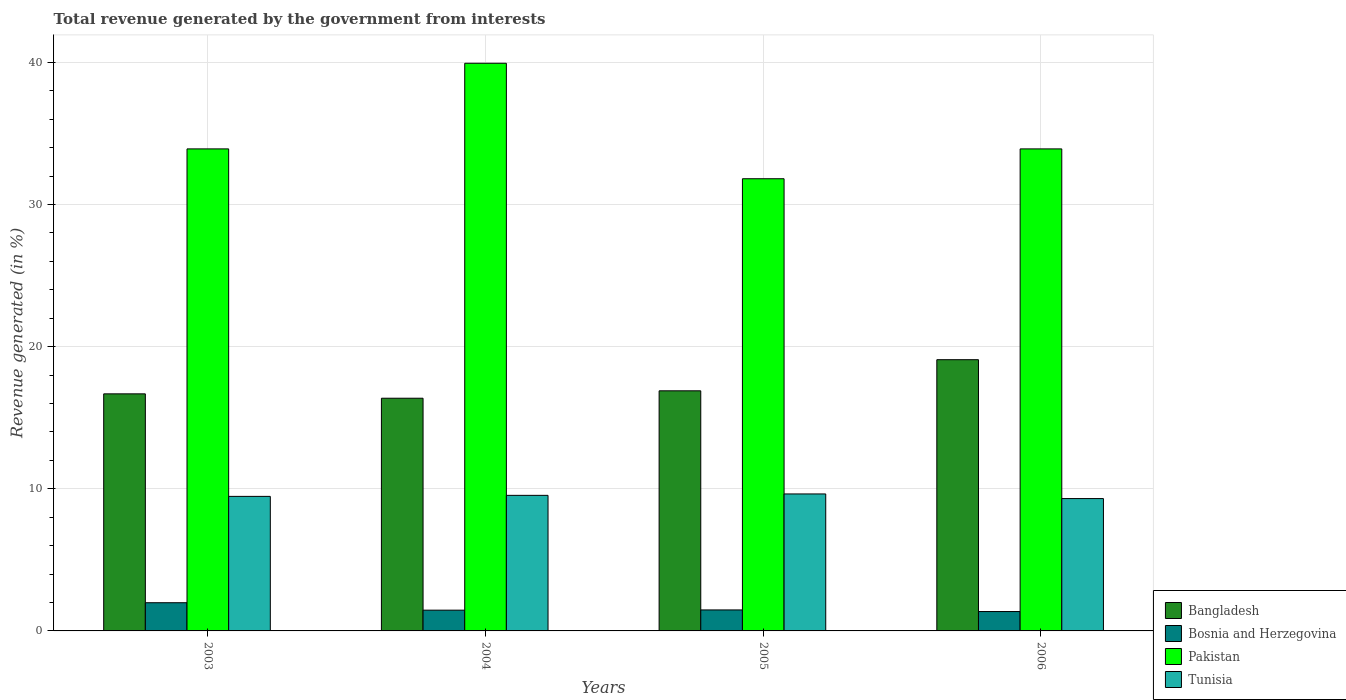How many groups of bars are there?
Keep it short and to the point. 4. Are the number of bars per tick equal to the number of legend labels?
Your response must be concise. Yes. Are the number of bars on each tick of the X-axis equal?
Your answer should be compact. Yes. How many bars are there on the 4th tick from the left?
Provide a succinct answer. 4. How many bars are there on the 1st tick from the right?
Provide a short and direct response. 4. What is the label of the 1st group of bars from the left?
Your response must be concise. 2003. In how many cases, is the number of bars for a given year not equal to the number of legend labels?
Provide a succinct answer. 0. What is the total revenue generated in Bosnia and Herzegovina in 2004?
Ensure brevity in your answer.  1.46. Across all years, what is the maximum total revenue generated in Bangladesh?
Your answer should be very brief. 19.08. Across all years, what is the minimum total revenue generated in Pakistan?
Offer a very short reply. 31.82. In which year was the total revenue generated in Tunisia minimum?
Offer a terse response. 2006. What is the total total revenue generated in Tunisia in the graph?
Provide a short and direct response. 37.95. What is the difference between the total revenue generated in Bosnia and Herzegovina in 2004 and that in 2005?
Provide a short and direct response. -0.02. What is the difference between the total revenue generated in Tunisia in 2005 and the total revenue generated in Bosnia and Herzegovina in 2006?
Give a very brief answer. 8.27. What is the average total revenue generated in Bangladesh per year?
Your answer should be very brief. 17.26. In the year 2004, what is the difference between the total revenue generated in Bangladesh and total revenue generated in Pakistan?
Give a very brief answer. -23.57. In how many years, is the total revenue generated in Tunisia greater than 28 %?
Provide a succinct answer. 0. What is the ratio of the total revenue generated in Tunisia in 2004 to that in 2006?
Make the answer very short. 1.02. Is the total revenue generated in Bangladesh in 2005 less than that in 2006?
Offer a terse response. Yes. Is the difference between the total revenue generated in Bangladesh in 2004 and 2006 greater than the difference between the total revenue generated in Pakistan in 2004 and 2006?
Keep it short and to the point. No. What is the difference between the highest and the second highest total revenue generated in Pakistan?
Keep it short and to the point. 6.03. What is the difference between the highest and the lowest total revenue generated in Bosnia and Herzegovina?
Ensure brevity in your answer.  0.62. In how many years, is the total revenue generated in Bangladesh greater than the average total revenue generated in Bangladesh taken over all years?
Keep it short and to the point. 1. What does the 2nd bar from the left in 2005 represents?
Ensure brevity in your answer.  Bosnia and Herzegovina. What does the 2nd bar from the right in 2006 represents?
Ensure brevity in your answer.  Pakistan. Is it the case that in every year, the sum of the total revenue generated in Tunisia and total revenue generated in Bangladesh is greater than the total revenue generated in Bosnia and Herzegovina?
Give a very brief answer. Yes. How many bars are there?
Give a very brief answer. 16. How many years are there in the graph?
Give a very brief answer. 4. Does the graph contain any zero values?
Give a very brief answer. No. Where does the legend appear in the graph?
Your response must be concise. Bottom right. How are the legend labels stacked?
Your answer should be compact. Vertical. What is the title of the graph?
Offer a very short reply. Total revenue generated by the government from interests. What is the label or title of the X-axis?
Your answer should be compact. Years. What is the label or title of the Y-axis?
Keep it short and to the point. Revenue generated (in %). What is the Revenue generated (in %) of Bangladesh in 2003?
Provide a short and direct response. 16.68. What is the Revenue generated (in %) of Bosnia and Herzegovina in 2003?
Offer a terse response. 1.98. What is the Revenue generated (in %) of Pakistan in 2003?
Ensure brevity in your answer.  33.92. What is the Revenue generated (in %) in Tunisia in 2003?
Offer a terse response. 9.47. What is the Revenue generated (in %) of Bangladesh in 2004?
Your answer should be very brief. 16.37. What is the Revenue generated (in %) in Bosnia and Herzegovina in 2004?
Your answer should be very brief. 1.46. What is the Revenue generated (in %) in Pakistan in 2004?
Provide a short and direct response. 39.94. What is the Revenue generated (in %) of Tunisia in 2004?
Your response must be concise. 9.54. What is the Revenue generated (in %) in Bangladesh in 2005?
Your answer should be compact. 16.89. What is the Revenue generated (in %) in Bosnia and Herzegovina in 2005?
Your response must be concise. 1.48. What is the Revenue generated (in %) of Pakistan in 2005?
Your response must be concise. 31.82. What is the Revenue generated (in %) of Tunisia in 2005?
Provide a short and direct response. 9.64. What is the Revenue generated (in %) of Bangladesh in 2006?
Your answer should be compact. 19.08. What is the Revenue generated (in %) in Bosnia and Herzegovina in 2006?
Provide a succinct answer. 1.36. What is the Revenue generated (in %) of Pakistan in 2006?
Offer a very short reply. 33.92. What is the Revenue generated (in %) of Tunisia in 2006?
Make the answer very short. 9.31. Across all years, what is the maximum Revenue generated (in %) of Bangladesh?
Offer a terse response. 19.08. Across all years, what is the maximum Revenue generated (in %) of Bosnia and Herzegovina?
Your response must be concise. 1.98. Across all years, what is the maximum Revenue generated (in %) in Pakistan?
Give a very brief answer. 39.94. Across all years, what is the maximum Revenue generated (in %) in Tunisia?
Offer a terse response. 9.64. Across all years, what is the minimum Revenue generated (in %) of Bangladesh?
Your answer should be compact. 16.37. Across all years, what is the minimum Revenue generated (in %) of Bosnia and Herzegovina?
Offer a terse response. 1.36. Across all years, what is the minimum Revenue generated (in %) in Pakistan?
Make the answer very short. 31.82. Across all years, what is the minimum Revenue generated (in %) of Tunisia?
Provide a succinct answer. 9.31. What is the total Revenue generated (in %) of Bangladesh in the graph?
Make the answer very short. 69.03. What is the total Revenue generated (in %) in Bosnia and Herzegovina in the graph?
Offer a very short reply. 6.29. What is the total Revenue generated (in %) of Pakistan in the graph?
Offer a terse response. 139.59. What is the total Revenue generated (in %) in Tunisia in the graph?
Offer a very short reply. 37.95. What is the difference between the Revenue generated (in %) in Bangladesh in 2003 and that in 2004?
Provide a short and direct response. 0.31. What is the difference between the Revenue generated (in %) of Bosnia and Herzegovina in 2003 and that in 2004?
Your response must be concise. 0.52. What is the difference between the Revenue generated (in %) in Pakistan in 2003 and that in 2004?
Make the answer very short. -6.03. What is the difference between the Revenue generated (in %) in Tunisia in 2003 and that in 2004?
Your response must be concise. -0.07. What is the difference between the Revenue generated (in %) in Bangladesh in 2003 and that in 2005?
Offer a very short reply. -0.21. What is the difference between the Revenue generated (in %) of Bosnia and Herzegovina in 2003 and that in 2005?
Make the answer very short. 0.51. What is the difference between the Revenue generated (in %) in Pakistan in 2003 and that in 2005?
Give a very brief answer. 2.1. What is the difference between the Revenue generated (in %) of Tunisia in 2003 and that in 2005?
Provide a short and direct response. -0.17. What is the difference between the Revenue generated (in %) of Bangladesh in 2003 and that in 2006?
Provide a succinct answer. -2.4. What is the difference between the Revenue generated (in %) of Bosnia and Herzegovina in 2003 and that in 2006?
Your answer should be compact. 0.62. What is the difference between the Revenue generated (in %) in Pakistan in 2003 and that in 2006?
Ensure brevity in your answer.  0. What is the difference between the Revenue generated (in %) in Tunisia in 2003 and that in 2006?
Your answer should be very brief. 0.15. What is the difference between the Revenue generated (in %) in Bangladesh in 2004 and that in 2005?
Offer a very short reply. -0.52. What is the difference between the Revenue generated (in %) in Bosnia and Herzegovina in 2004 and that in 2005?
Ensure brevity in your answer.  -0.02. What is the difference between the Revenue generated (in %) of Pakistan in 2004 and that in 2005?
Ensure brevity in your answer.  8.13. What is the difference between the Revenue generated (in %) of Tunisia in 2004 and that in 2005?
Offer a very short reply. -0.1. What is the difference between the Revenue generated (in %) in Bangladesh in 2004 and that in 2006?
Your answer should be very brief. -2.71. What is the difference between the Revenue generated (in %) in Bosnia and Herzegovina in 2004 and that in 2006?
Your response must be concise. 0.1. What is the difference between the Revenue generated (in %) of Pakistan in 2004 and that in 2006?
Ensure brevity in your answer.  6.03. What is the difference between the Revenue generated (in %) in Tunisia in 2004 and that in 2006?
Your response must be concise. 0.23. What is the difference between the Revenue generated (in %) in Bangladesh in 2005 and that in 2006?
Your answer should be very brief. -2.19. What is the difference between the Revenue generated (in %) in Bosnia and Herzegovina in 2005 and that in 2006?
Offer a very short reply. 0.11. What is the difference between the Revenue generated (in %) in Pakistan in 2005 and that in 2006?
Ensure brevity in your answer.  -2.1. What is the difference between the Revenue generated (in %) of Tunisia in 2005 and that in 2006?
Provide a short and direct response. 0.33. What is the difference between the Revenue generated (in %) in Bangladesh in 2003 and the Revenue generated (in %) in Bosnia and Herzegovina in 2004?
Offer a very short reply. 15.22. What is the difference between the Revenue generated (in %) of Bangladesh in 2003 and the Revenue generated (in %) of Pakistan in 2004?
Keep it short and to the point. -23.26. What is the difference between the Revenue generated (in %) in Bangladesh in 2003 and the Revenue generated (in %) in Tunisia in 2004?
Ensure brevity in your answer.  7.14. What is the difference between the Revenue generated (in %) of Bosnia and Herzegovina in 2003 and the Revenue generated (in %) of Pakistan in 2004?
Offer a very short reply. -37.96. What is the difference between the Revenue generated (in %) in Bosnia and Herzegovina in 2003 and the Revenue generated (in %) in Tunisia in 2004?
Your answer should be compact. -7.55. What is the difference between the Revenue generated (in %) of Pakistan in 2003 and the Revenue generated (in %) of Tunisia in 2004?
Your answer should be very brief. 24.38. What is the difference between the Revenue generated (in %) in Bangladesh in 2003 and the Revenue generated (in %) in Bosnia and Herzegovina in 2005?
Provide a succinct answer. 15.2. What is the difference between the Revenue generated (in %) of Bangladesh in 2003 and the Revenue generated (in %) of Pakistan in 2005?
Provide a succinct answer. -15.14. What is the difference between the Revenue generated (in %) of Bangladesh in 2003 and the Revenue generated (in %) of Tunisia in 2005?
Keep it short and to the point. 7.04. What is the difference between the Revenue generated (in %) of Bosnia and Herzegovina in 2003 and the Revenue generated (in %) of Pakistan in 2005?
Provide a short and direct response. -29.83. What is the difference between the Revenue generated (in %) in Bosnia and Herzegovina in 2003 and the Revenue generated (in %) in Tunisia in 2005?
Provide a succinct answer. -7.65. What is the difference between the Revenue generated (in %) of Pakistan in 2003 and the Revenue generated (in %) of Tunisia in 2005?
Your answer should be compact. 24.28. What is the difference between the Revenue generated (in %) of Bangladesh in 2003 and the Revenue generated (in %) of Bosnia and Herzegovina in 2006?
Ensure brevity in your answer.  15.32. What is the difference between the Revenue generated (in %) of Bangladesh in 2003 and the Revenue generated (in %) of Pakistan in 2006?
Your answer should be very brief. -17.23. What is the difference between the Revenue generated (in %) in Bangladesh in 2003 and the Revenue generated (in %) in Tunisia in 2006?
Ensure brevity in your answer.  7.37. What is the difference between the Revenue generated (in %) in Bosnia and Herzegovina in 2003 and the Revenue generated (in %) in Pakistan in 2006?
Your response must be concise. -31.93. What is the difference between the Revenue generated (in %) of Bosnia and Herzegovina in 2003 and the Revenue generated (in %) of Tunisia in 2006?
Your response must be concise. -7.33. What is the difference between the Revenue generated (in %) of Pakistan in 2003 and the Revenue generated (in %) of Tunisia in 2006?
Your response must be concise. 24.6. What is the difference between the Revenue generated (in %) in Bangladesh in 2004 and the Revenue generated (in %) in Bosnia and Herzegovina in 2005?
Offer a very short reply. 14.9. What is the difference between the Revenue generated (in %) of Bangladesh in 2004 and the Revenue generated (in %) of Pakistan in 2005?
Your answer should be very brief. -15.44. What is the difference between the Revenue generated (in %) in Bangladesh in 2004 and the Revenue generated (in %) in Tunisia in 2005?
Provide a short and direct response. 6.74. What is the difference between the Revenue generated (in %) of Bosnia and Herzegovina in 2004 and the Revenue generated (in %) of Pakistan in 2005?
Keep it short and to the point. -30.36. What is the difference between the Revenue generated (in %) of Bosnia and Herzegovina in 2004 and the Revenue generated (in %) of Tunisia in 2005?
Your answer should be very brief. -8.18. What is the difference between the Revenue generated (in %) of Pakistan in 2004 and the Revenue generated (in %) of Tunisia in 2005?
Provide a succinct answer. 30.3. What is the difference between the Revenue generated (in %) in Bangladesh in 2004 and the Revenue generated (in %) in Bosnia and Herzegovina in 2006?
Provide a short and direct response. 15.01. What is the difference between the Revenue generated (in %) of Bangladesh in 2004 and the Revenue generated (in %) of Pakistan in 2006?
Your response must be concise. -17.54. What is the difference between the Revenue generated (in %) in Bangladesh in 2004 and the Revenue generated (in %) in Tunisia in 2006?
Your answer should be compact. 7.06. What is the difference between the Revenue generated (in %) of Bosnia and Herzegovina in 2004 and the Revenue generated (in %) of Pakistan in 2006?
Make the answer very short. -32.46. What is the difference between the Revenue generated (in %) of Bosnia and Herzegovina in 2004 and the Revenue generated (in %) of Tunisia in 2006?
Give a very brief answer. -7.85. What is the difference between the Revenue generated (in %) of Pakistan in 2004 and the Revenue generated (in %) of Tunisia in 2006?
Give a very brief answer. 30.63. What is the difference between the Revenue generated (in %) in Bangladesh in 2005 and the Revenue generated (in %) in Bosnia and Herzegovina in 2006?
Make the answer very short. 15.53. What is the difference between the Revenue generated (in %) of Bangladesh in 2005 and the Revenue generated (in %) of Pakistan in 2006?
Give a very brief answer. -17.02. What is the difference between the Revenue generated (in %) of Bangladesh in 2005 and the Revenue generated (in %) of Tunisia in 2006?
Provide a short and direct response. 7.58. What is the difference between the Revenue generated (in %) of Bosnia and Herzegovina in 2005 and the Revenue generated (in %) of Pakistan in 2006?
Offer a very short reply. -32.44. What is the difference between the Revenue generated (in %) of Bosnia and Herzegovina in 2005 and the Revenue generated (in %) of Tunisia in 2006?
Provide a short and direct response. -7.83. What is the difference between the Revenue generated (in %) of Pakistan in 2005 and the Revenue generated (in %) of Tunisia in 2006?
Offer a very short reply. 22.5. What is the average Revenue generated (in %) in Bangladesh per year?
Ensure brevity in your answer.  17.26. What is the average Revenue generated (in %) of Bosnia and Herzegovina per year?
Your answer should be very brief. 1.57. What is the average Revenue generated (in %) in Pakistan per year?
Keep it short and to the point. 34.9. What is the average Revenue generated (in %) of Tunisia per year?
Make the answer very short. 9.49. In the year 2003, what is the difference between the Revenue generated (in %) of Bangladesh and Revenue generated (in %) of Bosnia and Herzegovina?
Your response must be concise. 14.7. In the year 2003, what is the difference between the Revenue generated (in %) of Bangladesh and Revenue generated (in %) of Pakistan?
Give a very brief answer. -17.24. In the year 2003, what is the difference between the Revenue generated (in %) in Bangladesh and Revenue generated (in %) in Tunisia?
Provide a short and direct response. 7.21. In the year 2003, what is the difference between the Revenue generated (in %) in Bosnia and Herzegovina and Revenue generated (in %) in Pakistan?
Provide a succinct answer. -31.93. In the year 2003, what is the difference between the Revenue generated (in %) in Bosnia and Herzegovina and Revenue generated (in %) in Tunisia?
Provide a short and direct response. -7.48. In the year 2003, what is the difference between the Revenue generated (in %) in Pakistan and Revenue generated (in %) in Tunisia?
Ensure brevity in your answer.  24.45. In the year 2004, what is the difference between the Revenue generated (in %) in Bangladesh and Revenue generated (in %) in Bosnia and Herzegovina?
Your answer should be compact. 14.91. In the year 2004, what is the difference between the Revenue generated (in %) in Bangladesh and Revenue generated (in %) in Pakistan?
Make the answer very short. -23.57. In the year 2004, what is the difference between the Revenue generated (in %) of Bangladesh and Revenue generated (in %) of Tunisia?
Provide a short and direct response. 6.83. In the year 2004, what is the difference between the Revenue generated (in %) of Bosnia and Herzegovina and Revenue generated (in %) of Pakistan?
Ensure brevity in your answer.  -38.48. In the year 2004, what is the difference between the Revenue generated (in %) of Bosnia and Herzegovina and Revenue generated (in %) of Tunisia?
Give a very brief answer. -8.08. In the year 2004, what is the difference between the Revenue generated (in %) in Pakistan and Revenue generated (in %) in Tunisia?
Your answer should be compact. 30.4. In the year 2005, what is the difference between the Revenue generated (in %) in Bangladesh and Revenue generated (in %) in Bosnia and Herzegovina?
Offer a terse response. 15.42. In the year 2005, what is the difference between the Revenue generated (in %) in Bangladesh and Revenue generated (in %) in Pakistan?
Provide a short and direct response. -14.92. In the year 2005, what is the difference between the Revenue generated (in %) in Bangladesh and Revenue generated (in %) in Tunisia?
Make the answer very short. 7.26. In the year 2005, what is the difference between the Revenue generated (in %) of Bosnia and Herzegovina and Revenue generated (in %) of Pakistan?
Provide a succinct answer. -30.34. In the year 2005, what is the difference between the Revenue generated (in %) of Bosnia and Herzegovina and Revenue generated (in %) of Tunisia?
Provide a short and direct response. -8.16. In the year 2005, what is the difference between the Revenue generated (in %) in Pakistan and Revenue generated (in %) in Tunisia?
Your answer should be compact. 22.18. In the year 2006, what is the difference between the Revenue generated (in %) of Bangladesh and Revenue generated (in %) of Bosnia and Herzegovina?
Give a very brief answer. 17.72. In the year 2006, what is the difference between the Revenue generated (in %) of Bangladesh and Revenue generated (in %) of Pakistan?
Your answer should be very brief. -14.83. In the year 2006, what is the difference between the Revenue generated (in %) of Bangladesh and Revenue generated (in %) of Tunisia?
Make the answer very short. 9.77. In the year 2006, what is the difference between the Revenue generated (in %) of Bosnia and Herzegovina and Revenue generated (in %) of Pakistan?
Give a very brief answer. -32.55. In the year 2006, what is the difference between the Revenue generated (in %) in Bosnia and Herzegovina and Revenue generated (in %) in Tunisia?
Your response must be concise. -7.95. In the year 2006, what is the difference between the Revenue generated (in %) in Pakistan and Revenue generated (in %) in Tunisia?
Offer a very short reply. 24.6. What is the ratio of the Revenue generated (in %) of Bangladesh in 2003 to that in 2004?
Provide a succinct answer. 1.02. What is the ratio of the Revenue generated (in %) of Bosnia and Herzegovina in 2003 to that in 2004?
Make the answer very short. 1.36. What is the ratio of the Revenue generated (in %) in Pakistan in 2003 to that in 2004?
Make the answer very short. 0.85. What is the ratio of the Revenue generated (in %) of Bangladesh in 2003 to that in 2005?
Keep it short and to the point. 0.99. What is the ratio of the Revenue generated (in %) in Bosnia and Herzegovina in 2003 to that in 2005?
Your answer should be very brief. 1.34. What is the ratio of the Revenue generated (in %) of Pakistan in 2003 to that in 2005?
Offer a very short reply. 1.07. What is the ratio of the Revenue generated (in %) of Tunisia in 2003 to that in 2005?
Provide a short and direct response. 0.98. What is the ratio of the Revenue generated (in %) in Bangladesh in 2003 to that in 2006?
Keep it short and to the point. 0.87. What is the ratio of the Revenue generated (in %) in Bosnia and Herzegovina in 2003 to that in 2006?
Give a very brief answer. 1.46. What is the ratio of the Revenue generated (in %) in Pakistan in 2003 to that in 2006?
Your answer should be compact. 1. What is the ratio of the Revenue generated (in %) in Tunisia in 2003 to that in 2006?
Make the answer very short. 1.02. What is the ratio of the Revenue generated (in %) in Bangladesh in 2004 to that in 2005?
Ensure brevity in your answer.  0.97. What is the ratio of the Revenue generated (in %) of Bosnia and Herzegovina in 2004 to that in 2005?
Make the answer very short. 0.99. What is the ratio of the Revenue generated (in %) in Pakistan in 2004 to that in 2005?
Your answer should be compact. 1.26. What is the ratio of the Revenue generated (in %) of Tunisia in 2004 to that in 2005?
Offer a terse response. 0.99. What is the ratio of the Revenue generated (in %) of Bangladesh in 2004 to that in 2006?
Ensure brevity in your answer.  0.86. What is the ratio of the Revenue generated (in %) of Bosnia and Herzegovina in 2004 to that in 2006?
Give a very brief answer. 1.07. What is the ratio of the Revenue generated (in %) in Pakistan in 2004 to that in 2006?
Give a very brief answer. 1.18. What is the ratio of the Revenue generated (in %) in Tunisia in 2004 to that in 2006?
Your answer should be compact. 1.02. What is the ratio of the Revenue generated (in %) of Bangladesh in 2005 to that in 2006?
Your answer should be very brief. 0.89. What is the ratio of the Revenue generated (in %) in Bosnia and Herzegovina in 2005 to that in 2006?
Offer a very short reply. 1.08. What is the ratio of the Revenue generated (in %) in Pakistan in 2005 to that in 2006?
Provide a short and direct response. 0.94. What is the ratio of the Revenue generated (in %) of Tunisia in 2005 to that in 2006?
Offer a terse response. 1.03. What is the difference between the highest and the second highest Revenue generated (in %) of Bangladesh?
Offer a terse response. 2.19. What is the difference between the highest and the second highest Revenue generated (in %) of Bosnia and Herzegovina?
Provide a succinct answer. 0.51. What is the difference between the highest and the second highest Revenue generated (in %) of Pakistan?
Your answer should be compact. 6.03. What is the difference between the highest and the second highest Revenue generated (in %) in Tunisia?
Keep it short and to the point. 0.1. What is the difference between the highest and the lowest Revenue generated (in %) of Bangladesh?
Offer a very short reply. 2.71. What is the difference between the highest and the lowest Revenue generated (in %) of Bosnia and Herzegovina?
Give a very brief answer. 0.62. What is the difference between the highest and the lowest Revenue generated (in %) of Pakistan?
Provide a short and direct response. 8.13. What is the difference between the highest and the lowest Revenue generated (in %) in Tunisia?
Make the answer very short. 0.33. 